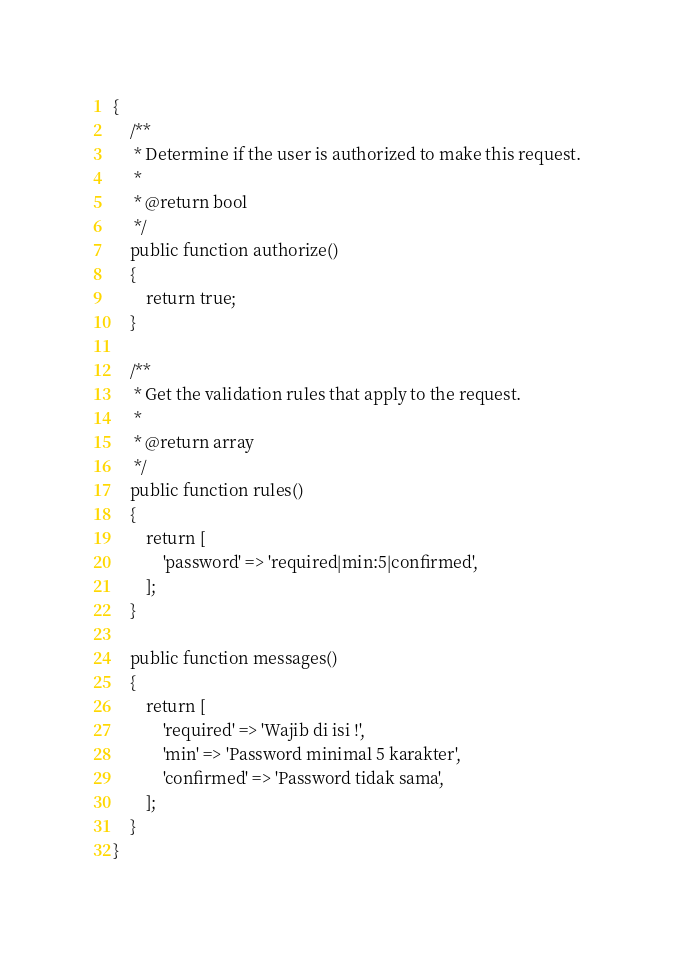<code> <loc_0><loc_0><loc_500><loc_500><_PHP_>{
    /**
     * Determine if the user is authorized to make this request.
     *
     * @return bool
     */
    public function authorize()
    {
        return true;
    }

    /**
     * Get the validation rules that apply to the request.
     *
     * @return array
     */
    public function rules()
    {
        return [
            'password' => 'required|min:5|confirmed',
        ];
    }

    public function messages()
    {
        return [
            'required' => 'Wajib di isi !',
            'min' => 'Password minimal 5 karakter',
            'confirmed' => 'Password tidak sama',
        ];
    }
}
</code> 